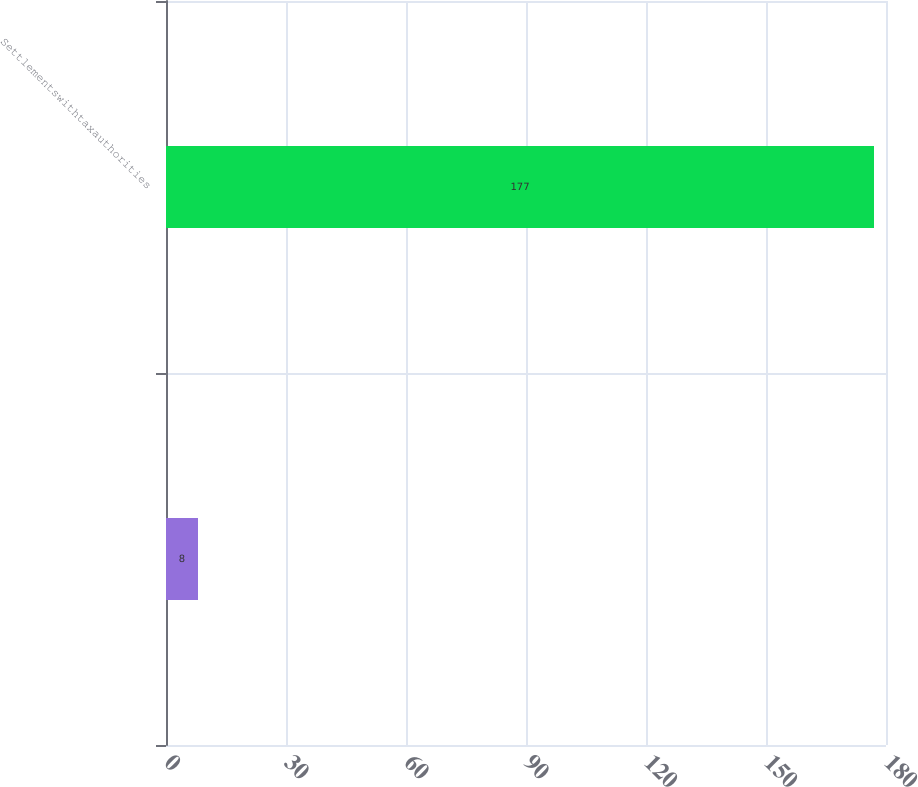Convert chart to OTSL. <chart><loc_0><loc_0><loc_500><loc_500><bar_chart><ecel><fcel>Settlementswithtaxauthorities<nl><fcel>8<fcel>177<nl></chart> 